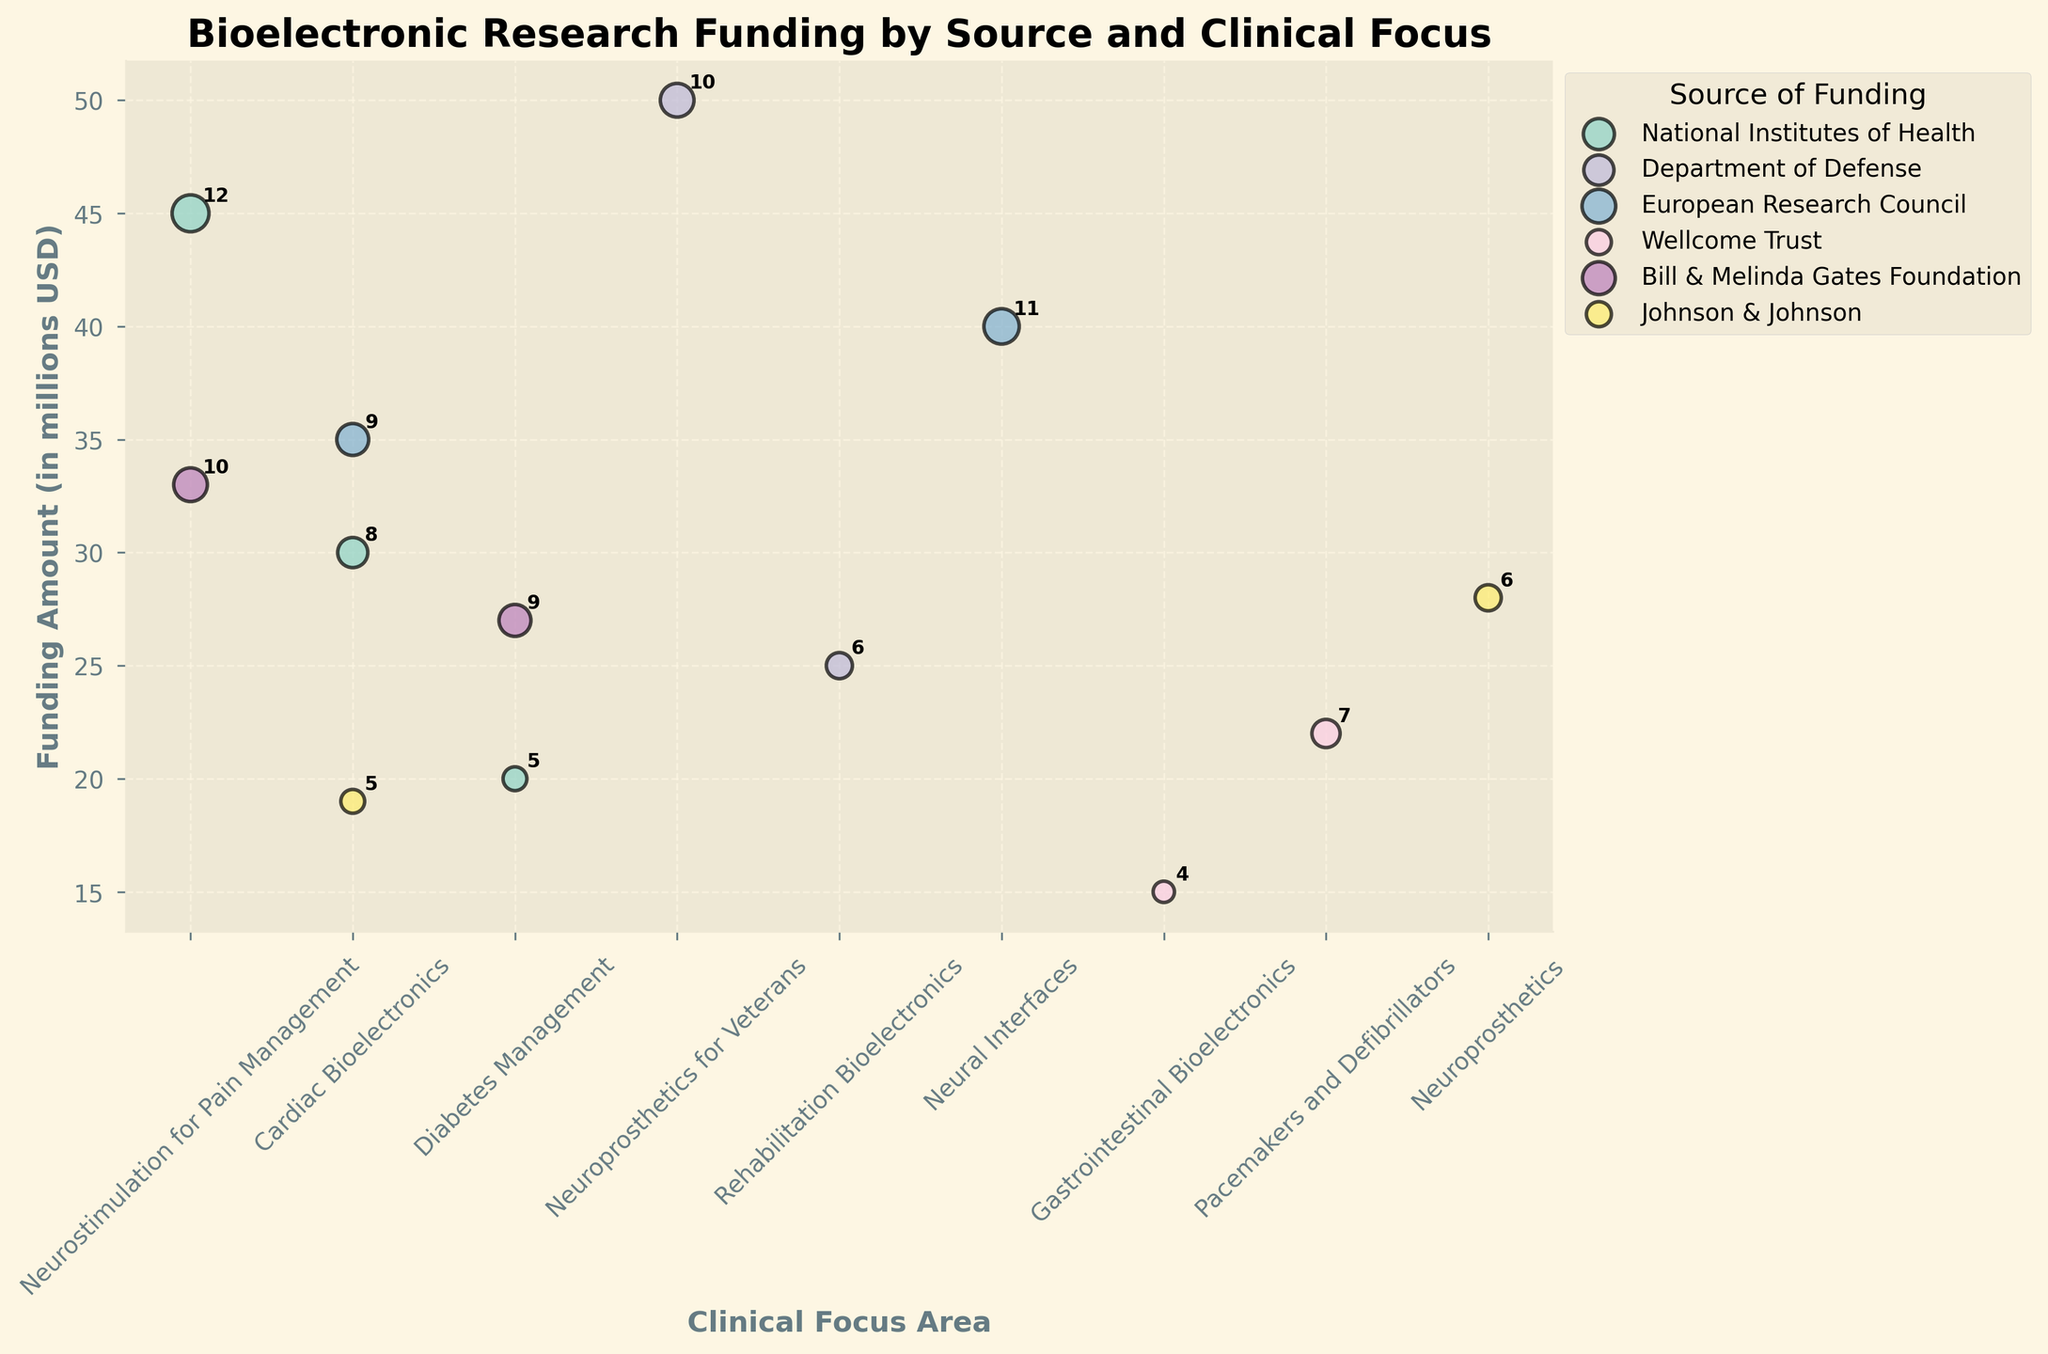What's the title of the figure? The title is typically displayed prominently at the top of the figure. It helps to quickly understand what the entire chart represents. In this case, from the given plot details, the title is "Bioelectronic Research Funding by Source and Clinical Focus."
Answer: Bioelectronic Research Funding by Source and Clinical Focus What are the labeled axes in the figure? The labeled axes help to understand what each axis represents. The x-axis is labeled "Clinical Focus Area," showing different clinical focus areas, and the y-axis is labeled "Funding Amount (in millions USD)," showing the funding amounts in millions of USD.
Answer: Clinical Focus Area (x-axis), Funding Amount (in millions USD) (y-axis) Which source of funding has the largest bubble, and for which clinical focus area? The size of the bubbles corresponds to the number of projects. The largest bubble indicates the highest number of projects. By checking the plot, the Department of Defense has the largest bubble for the "Neuroprosthetics for Veterans" clinical focus area.
Answer: Department of Defense, Neuroprosthetics for Veterans What is the total amount of funding received by the "Cardiac Bioelectronics" clinical focus area across all sources? Add the funding amounts from different sources for the "Cardiac Bioelectronics" area: National Institutes of Health (30), European Research Council (35), and Johnson & Johnson (19). (30 + 35 + 19) = 84 million USD.
Answer: 84 million USD Which clinical focus area received the highest funding from the Bill & Melinda Gates Foundation? Look at the bubbles for the Bill & Melinda Gates Foundation. Compare the funding amounts for the respective clinical focus areas. "Neurostimulation for Pain Management" has a funding of 33 million USD, which is higher than "Diabetes Management" (27 million USD).
Answer: Neurostimulation for Pain Management Compare the funding amounts for "Neurostimulation for Pain Management" between National Institutes of Health and Bill & Melinda Gates Foundation. Which has more funding? The bubble size and positions for "Neurostimulation for Pain Management" are compared. NIH has a funding amount of 45 million USD, and Bill & Melinda Gates Foundation has 33 million USD. NIH has more funding.
Answer: National Institutes of Health How many clinical focus areas are funded by the European Research Council? Count the different horizontal positions (clinical focus areas) linked to the European Research Council. There are two: "Neural Interfaces" and "Cardiac Bioelectronics."
Answer: 2 What is the smallest funding amount, and which clinical focus area and source does it belong to? Check the y-axis positions for the lowest bubble point and the respective source. The smallest funding amount is 15 million USD, which belongs to the "Gastrointestinal Bioelectronics" clinical focus area funded by the Wellcome Trust.
Answer: 15 million USD, Gastrointestinal Bioelectronics, Wellcome Trust What is the average number of projects for the clinical area "Neuroprosthetics" across all funding sources? Sum the number of projects for "Neuroprosthetics" from different sources: Department of Defense has 10 and Johnson & Johnson has 6. Average = (10 + 6) / 2 = 8.
Answer: 8 